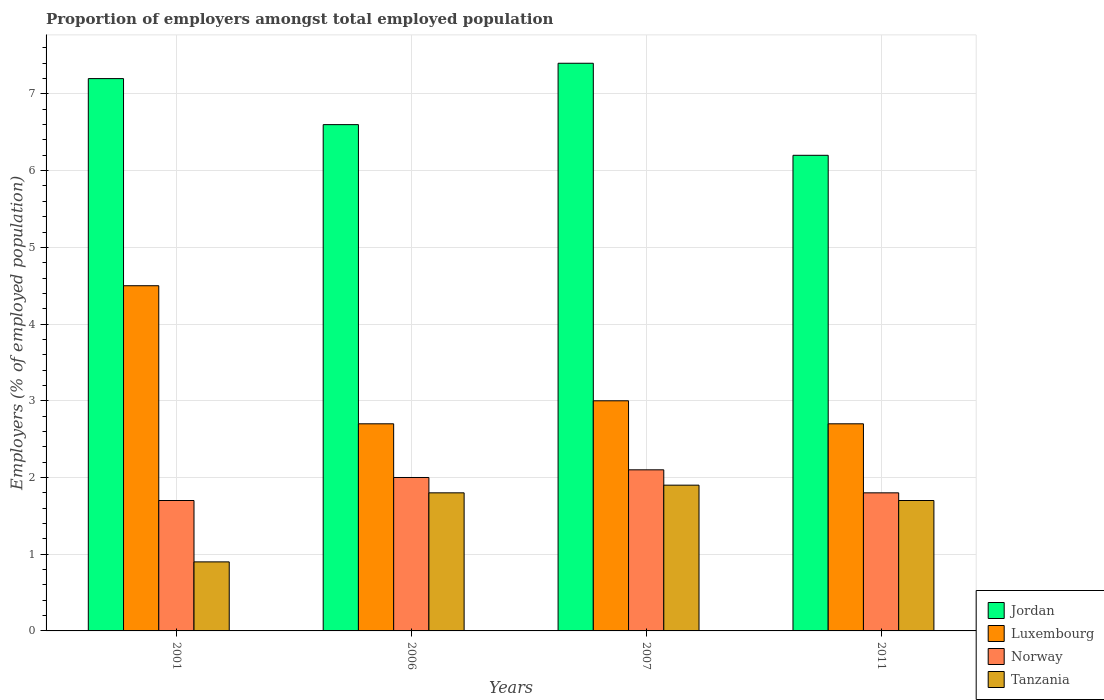How many groups of bars are there?
Provide a succinct answer. 4. Are the number of bars per tick equal to the number of legend labels?
Ensure brevity in your answer.  Yes. Are the number of bars on each tick of the X-axis equal?
Provide a succinct answer. Yes. What is the label of the 3rd group of bars from the left?
Your answer should be very brief. 2007. In how many cases, is the number of bars for a given year not equal to the number of legend labels?
Keep it short and to the point. 0. What is the proportion of employers in Jordan in 2006?
Your response must be concise. 6.6. Across all years, what is the maximum proportion of employers in Norway?
Your response must be concise. 2.1. Across all years, what is the minimum proportion of employers in Luxembourg?
Keep it short and to the point. 2.7. In which year was the proportion of employers in Norway maximum?
Give a very brief answer. 2007. What is the total proportion of employers in Luxembourg in the graph?
Provide a succinct answer. 12.9. What is the difference between the proportion of employers in Tanzania in 2006 and that in 2011?
Your response must be concise. 0.1. What is the difference between the proportion of employers in Luxembourg in 2007 and the proportion of employers in Tanzania in 2006?
Your answer should be very brief. 1.2. What is the average proportion of employers in Jordan per year?
Provide a short and direct response. 6.85. In the year 2001, what is the difference between the proportion of employers in Jordan and proportion of employers in Tanzania?
Keep it short and to the point. 6.3. In how many years, is the proportion of employers in Luxembourg greater than 5.2 %?
Provide a short and direct response. 0. What is the ratio of the proportion of employers in Luxembourg in 2001 to that in 2006?
Keep it short and to the point. 1.67. Is the proportion of employers in Luxembourg in 2006 less than that in 2007?
Give a very brief answer. Yes. Is the difference between the proportion of employers in Jordan in 2001 and 2007 greater than the difference between the proportion of employers in Tanzania in 2001 and 2007?
Your answer should be very brief. Yes. What is the difference between the highest and the second highest proportion of employers in Tanzania?
Make the answer very short. 0.1. What is the difference between the highest and the lowest proportion of employers in Luxembourg?
Your response must be concise. 1.8. What does the 3rd bar from the left in 2006 represents?
Your answer should be compact. Norway. What does the 3rd bar from the right in 2011 represents?
Ensure brevity in your answer.  Luxembourg. Is it the case that in every year, the sum of the proportion of employers in Luxembourg and proportion of employers in Norway is greater than the proportion of employers in Jordan?
Offer a very short reply. No. What is the difference between two consecutive major ticks on the Y-axis?
Your answer should be compact. 1. Where does the legend appear in the graph?
Your answer should be compact. Bottom right. What is the title of the graph?
Offer a very short reply. Proportion of employers amongst total employed population. What is the label or title of the X-axis?
Offer a terse response. Years. What is the label or title of the Y-axis?
Offer a terse response. Employers (% of employed population). What is the Employers (% of employed population) of Jordan in 2001?
Keep it short and to the point. 7.2. What is the Employers (% of employed population) of Norway in 2001?
Offer a very short reply. 1.7. What is the Employers (% of employed population) of Tanzania in 2001?
Give a very brief answer. 0.9. What is the Employers (% of employed population) of Jordan in 2006?
Give a very brief answer. 6.6. What is the Employers (% of employed population) in Luxembourg in 2006?
Your answer should be very brief. 2.7. What is the Employers (% of employed population) in Tanzania in 2006?
Make the answer very short. 1.8. What is the Employers (% of employed population) of Jordan in 2007?
Keep it short and to the point. 7.4. What is the Employers (% of employed population) of Luxembourg in 2007?
Your answer should be compact. 3. What is the Employers (% of employed population) of Norway in 2007?
Provide a succinct answer. 2.1. What is the Employers (% of employed population) of Tanzania in 2007?
Offer a terse response. 1.9. What is the Employers (% of employed population) of Jordan in 2011?
Your response must be concise. 6.2. What is the Employers (% of employed population) in Luxembourg in 2011?
Keep it short and to the point. 2.7. What is the Employers (% of employed population) of Norway in 2011?
Offer a very short reply. 1.8. What is the Employers (% of employed population) in Tanzania in 2011?
Give a very brief answer. 1.7. Across all years, what is the maximum Employers (% of employed population) of Jordan?
Provide a succinct answer. 7.4. Across all years, what is the maximum Employers (% of employed population) of Norway?
Give a very brief answer. 2.1. Across all years, what is the maximum Employers (% of employed population) in Tanzania?
Your answer should be very brief. 1.9. Across all years, what is the minimum Employers (% of employed population) in Jordan?
Ensure brevity in your answer.  6.2. Across all years, what is the minimum Employers (% of employed population) in Luxembourg?
Your answer should be very brief. 2.7. Across all years, what is the minimum Employers (% of employed population) in Norway?
Your response must be concise. 1.7. Across all years, what is the minimum Employers (% of employed population) of Tanzania?
Make the answer very short. 0.9. What is the total Employers (% of employed population) of Jordan in the graph?
Give a very brief answer. 27.4. What is the total Employers (% of employed population) in Luxembourg in the graph?
Give a very brief answer. 12.9. What is the total Employers (% of employed population) of Tanzania in the graph?
Your response must be concise. 6.3. What is the difference between the Employers (% of employed population) of Norway in 2001 and that in 2006?
Offer a terse response. -0.3. What is the difference between the Employers (% of employed population) of Tanzania in 2001 and that in 2006?
Make the answer very short. -0.9. What is the difference between the Employers (% of employed population) in Norway in 2001 and that in 2007?
Provide a short and direct response. -0.4. What is the difference between the Employers (% of employed population) in Tanzania in 2001 and that in 2007?
Ensure brevity in your answer.  -1. What is the difference between the Employers (% of employed population) of Jordan in 2001 and that in 2011?
Provide a short and direct response. 1. What is the difference between the Employers (% of employed population) of Luxembourg in 2001 and that in 2011?
Provide a succinct answer. 1.8. What is the difference between the Employers (% of employed population) of Norway in 2001 and that in 2011?
Provide a short and direct response. -0.1. What is the difference between the Employers (% of employed population) in Norway in 2006 and that in 2007?
Ensure brevity in your answer.  -0.1. What is the difference between the Employers (% of employed population) of Tanzania in 2006 and that in 2007?
Provide a succinct answer. -0.1. What is the difference between the Employers (% of employed population) of Jordan in 2007 and that in 2011?
Offer a terse response. 1.2. What is the difference between the Employers (% of employed population) in Luxembourg in 2007 and that in 2011?
Provide a succinct answer. 0.3. What is the difference between the Employers (% of employed population) in Norway in 2007 and that in 2011?
Your answer should be very brief. 0.3. What is the difference between the Employers (% of employed population) in Jordan in 2001 and the Employers (% of employed population) in Norway in 2006?
Make the answer very short. 5.2. What is the difference between the Employers (% of employed population) of Jordan in 2001 and the Employers (% of employed population) of Tanzania in 2006?
Offer a terse response. 5.4. What is the difference between the Employers (% of employed population) in Norway in 2001 and the Employers (% of employed population) in Tanzania in 2006?
Make the answer very short. -0.1. What is the difference between the Employers (% of employed population) of Jordan in 2001 and the Employers (% of employed population) of Luxembourg in 2007?
Offer a terse response. 4.2. What is the difference between the Employers (% of employed population) in Jordan in 2001 and the Employers (% of employed population) in Norway in 2007?
Your response must be concise. 5.1. What is the difference between the Employers (% of employed population) in Jordan in 2001 and the Employers (% of employed population) in Norway in 2011?
Offer a terse response. 5.4. What is the difference between the Employers (% of employed population) in Luxembourg in 2001 and the Employers (% of employed population) in Norway in 2011?
Keep it short and to the point. 2.7. What is the difference between the Employers (% of employed population) in Luxembourg in 2001 and the Employers (% of employed population) in Tanzania in 2011?
Offer a terse response. 2.8. What is the difference between the Employers (% of employed population) in Luxembourg in 2006 and the Employers (% of employed population) in Tanzania in 2007?
Ensure brevity in your answer.  0.8. What is the difference between the Employers (% of employed population) of Norway in 2006 and the Employers (% of employed population) of Tanzania in 2007?
Ensure brevity in your answer.  0.1. What is the difference between the Employers (% of employed population) in Jordan in 2006 and the Employers (% of employed population) in Norway in 2011?
Your response must be concise. 4.8. What is the difference between the Employers (% of employed population) of Luxembourg in 2006 and the Employers (% of employed population) of Norway in 2011?
Your answer should be very brief. 0.9. What is the difference between the Employers (% of employed population) of Luxembourg in 2006 and the Employers (% of employed population) of Tanzania in 2011?
Keep it short and to the point. 1. What is the difference between the Employers (% of employed population) in Norway in 2006 and the Employers (% of employed population) in Tanzania in 2011?
Offer a very short reply. 0.3. What is the difference between the Employers (% of employed population) of Jordan in 2007 and the Employers (% of employed population) of Luxembourg in 2011?
Keep it short and to the point. 4.7. What is the difference between the Employers (% of employed population) in Jordan in 2007 and the Employers (% of employed population) in Norway in 2011?
Your response must be concise. 5.6. What is the difference between the Employers (% of employed population) of Luxembourg in 2007 and the Employers (% of employed population) of Norway in 2011?
Keep it short and to the point. 1.2. What is the difference between the Employers (% of employed population) in Luxembourg in 2007 and the Employers (% of employed population) in Tanzania in 2011?
Offer a terse response. 1.3. What is the difference between the Employers (% of employed population) of Norway in 2007 and the Employers (% of employed population) of Tanzania in 2011?
Offer a terse response. 0.4. What is the average Employers (% of employed population) of Jordan per year?
Make the answer very short. 6.85. What is the average Employers (% of employed population) in Luxembourg per year?
Your response must be concise. 3.23. What is the average Employers (% of employed population) of Norway per year?
Offer a terse response. 1.9. What is the average Employers (% of employed population) in Tanzania per year?
Your answer should be very brief. 1.57. In the year 2001, what is the difference between the Employers (% of employed population) of Jordan and Employers (% of employed population) of Tanzania?
Your response must be concise. 6.3. In the year 2001, what is the difference between the Employers (% of employed population) of Luxembourg and Employers (% of employed population) of Tanzania?
Provide a short and direct response. 3.6. In the year 2001, what is the difference between the Employers (% of employed population) in Norway and Employers (% of employed population) in Tanzania?
Keep it short and to the point. 0.8. In the year 2006, what is the difference between the Employers (% of employed population) in Jordan and Employers (% of employed population) in Norway?
Make the answer very short. 4.6. In the year 2006, what is the difference between the Employers (% of employed population) in Jordan and Employers (% of employed population) in Tanzania?
Provide a short and direct response. 4.8. In the year 2006, what is the difference between the Employers (% of employed population) of Luxembourg and Employers (% of employed population) of Tanzania?
Keep it short and to the point. 0.9. In the year 2007, what is the difference between the Employers (% of employed population) of Luxembourg and Employers (% of employed population) of Norway?
Your answer should be very brief. 0.9. In the year 2007, what is the difference between the Employers (% of employed population) in Norway and Employers (% of employed population) in Tanzania?
Your response must be concise. 0.2. In the year 2011, what is the difference between the Employers (% of employed population) of Luxembourg and Employers (% of employed population) of Tanzania?
Your answer should be compact. 1. In the year 2011, what is the difference between the Employers (% of employed population) in Norway and Employers (% of employed population) in Tanzania?
Offer a terse response. 0.1. What is the ratio of the Employers (% of employed population) of Luxembourg in 2001 to that in 2006?
Keep it short and to the point. 1.67. What is the ratio of the Employers (% of employed population) of Tanzania in 2001 to that in 2006?
Offer a very short reply. 0.5. What is the ratio of the Employers (% of employed population) in Jordan in 2001 to that in 2007?
Offer a very short reply. 0.97. What is the ratio of the Employers (% of employed population) in Luxembourg in 2001 to that in 2007?
Provide a succinct answer. 1.5. What is the ratio of the Employers (% of employed population) in Norway in 2001 to that in 2007?
Ensure brevity in your answer.  0.81. What is the ratio of the Employers (% of employed population) of Tanzania in 2001 to that in 2007?
Provide a short and direct response. 0.47. What is the ratio of the Employers (% of employed population) of Jordan in 2001 to that in 2011?
Ensure brevity in your answer.  1.16. What is the ratio of the Employers (% of employed population) of Luxembourg in 2001 to that in 2011?
Provide a short and direct response. 1.67. What is the ratio of the Employers (% of employed population) of Tanzania in 2001 to that in 2011?
Give a very brief answer. 0.53. What is the ratio of the Employers (% of employed population) of Jordan in 2006 to that in 2007?
Provide a succinct answer. 0.89. What is the ratio of the Employers (% of employed population) in Luxembourg in 2006 to that in 2007?
Offer a very short reply. 0.9. What is the ratio of the Employers (% of employed population) in Norway in 2006 to that in 2007?
Give a very brief answer. 0.95. What is the ratio of the Employers (% of employed population) of Tanzania in 2006 to that in 2007?
Provide a short and direct response. 0.95. What is the ratio of the Employers (% of employed population) of Jordan in 2006 to that in 2011?
Offer a terse response. 1.06. What is the ratio of the Employers (% of employed population) of Norway in 2006 to that in 2011?
Make the answer very short. 1.11. What is the ratio of the Employers (% of employed population) in Tanzania in 2006 to that in 2011?
Provide a short and direct response. 1.06. What is the ratio of the Employers (% of employed population) of Jordan in 2007 to that in 2011?
Give a very brief answer. 1.19. What is the ratio of the Employers (% of employed population) of Tanzania in 2007 to that in 2011?
Make the answer very short. 1.12. What is the difference between the highest and the lowest Employers (% of employed population) in Jordan?
Keep it short and to the point. 1.2. What is the difference between the highest and the lowest Employers (% of employed population) of Tanzania?
Offer a very short reply. 1. 